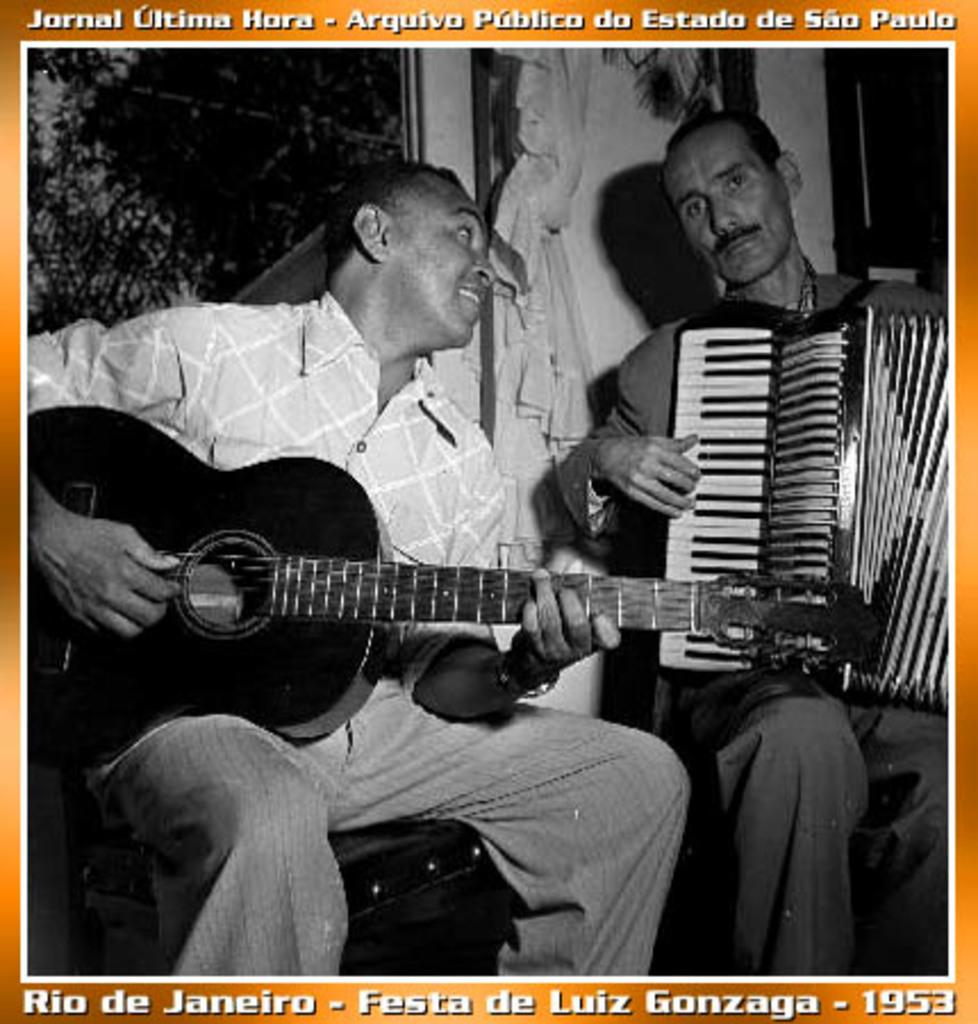What is the color scheme of the image? The image is black and white. How many people are in the image? There are two men in the image. What are the men doing in the image? The men are sitting on chairs and playing musical instruments. What type of yam is being served as a side dish during the meal in the image? There is no meal or yam present in the image; it features two men playing musical instruments while sitting on chairs. 